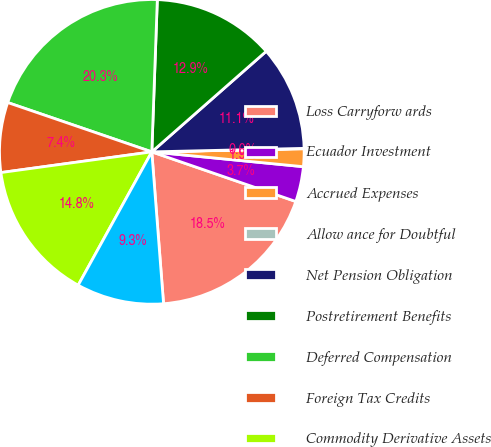Convert chart. <chart><loc_0><loc_0><loc_500><loc_500><pie_chart><fcel>Loss Carryforw ards<fcel>Ecuador Investment<fcel>Accrued Expenses<fcel>Allow ance for Doubtful<fcel>Net Pension Obligation<fcel>Postretirement Benefits<fcel>Deferred Compensation<fcel>Foreign Tax Credits<fcel>Commodity Derivative Assets<fcel>Other<nl><fcel>18.49%<fcel>3.73%<fcel>1.88%<fcel>0.04%<fcel>11.11%<fcel>12.95%<fcel>20.33%<fcel>7.42%<fcel>14.8%<fcel>9.26%<nl></chart> 